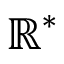Convert formula to latex. <formula><loc_0><loc_0><loc_500><loc_500>\mathbb { R } ^ { * }</formula> 